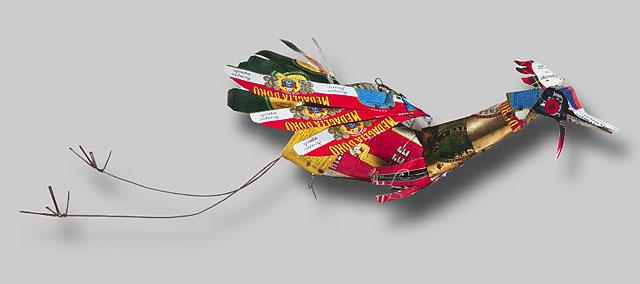What materials can be identified in this sculpture, and how do they contribute to its overall aesthetic? In this sculpture, you can spot various materials including tin cans, bottle caps, and wire. The vibrant and varied colors of the tin can pieces, ranging from red and green to blue and yellow, give the bird a lively, colorful appearance which captures attention. The use of everyday materials like bottle caps for the eyes and beak adds a playful, inventive twist, while the wire used for the legs suggests delicacy and fragility, contrasting with the sturdier body. This selection and placement of materials not only showcases the artist's creativity but also contributes to a unique texture and form that defines this piece of folk art. 